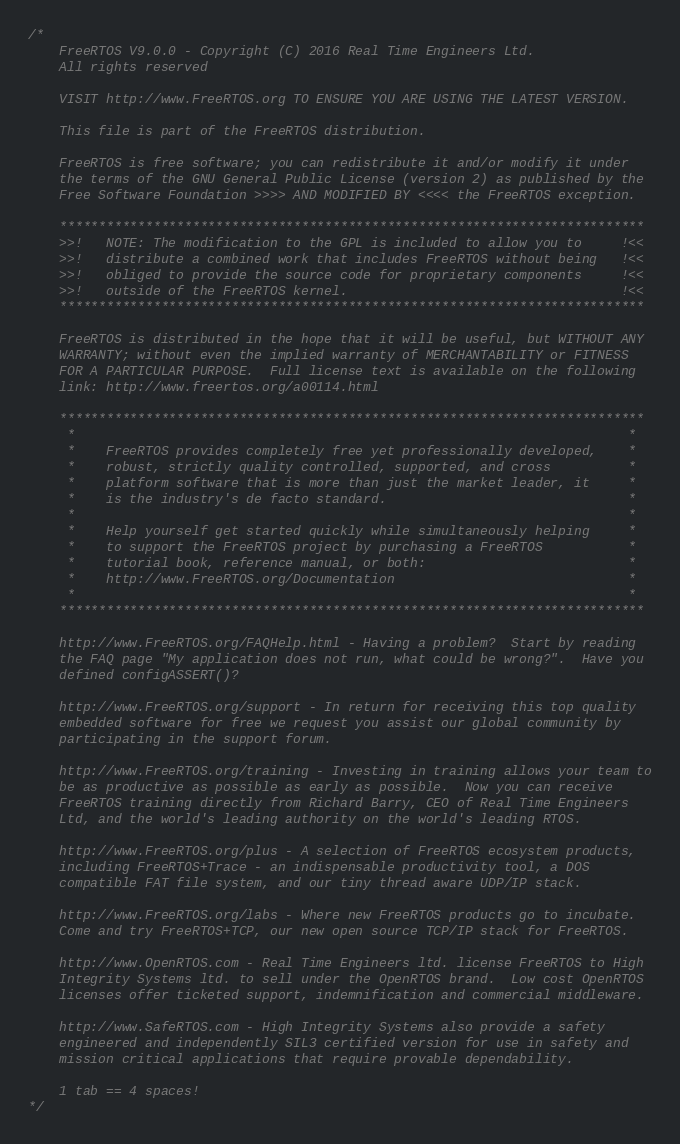Convert code to text. <code><loc_0><loc_0><loc_500><loc_500><_C_>/*
    FreeRTOS V9.0.0 - Copyright (C) 2016 Real Time Engineers Ltd.
    All rights reserved

    VISIT http://www.FreeRTOS.org TO ENSURE YOU ARE USING THE LATEST VERSION.

    This file is part of the FreeRTOS distribution.

    FreeRTOS is free software; you can redistribute it and/or modify it under
    the terms of the GNU General Public License (version 2) as published by the
    Free Software Foundation >>>> AND MODIFIED BY <<<< the FreeRTOS exception.

    ***************************************************************************
    >>!   NOTE: The modification to the GPL is included to allow you to     !<<
    >>!   distribute a combined work that includes FreeRTOS without being   !<<
    >>!   obliged to provide the source code for proprietary components     !<<
    >>!   outside of the FreeRTOS kernel.                                   !<<
    ***************************************************************************

    FreeRTOS is distributed in the hope that it will be useful, but WITHOUT ANY
    WARRANTY; without even the implied warranty of MERCHANTABILITY or FITNESS
    FOR A PARTICULAR PURPOSE.  Full license text is available on the following
    link: http://www.freertos.org/a00114.html

    ***************************************************************************
     *                                                                       *
     *    FreeRTOS provides completely free yet professionally developed,    *
     *    robust, strictly quality controlled, supported, and cross          *
     *    platform software that is more than just the market leader, it     *
     *    is the industry's de facto standard.                               *
     *                                                                       *
     *    Help yourself get started quickly while simultaneously helping     *
     *    to support the FreeRTOS project by purchasing a FreeRTOS           *
     *    tutorial book, reference manual, or both:                          *
     *    http://www.FreeRTOS.org/Documentation                              *
     *                                                                       *
    ***************************************************************************

    http://www.FreeRTOS.org/FAQHelp.html - Having a problem?  Start by reading
    the FAQ page "My application does not run, what could be wrong?".  Have you
    defined configASSERT()?

    http://www.FreeRTOS.org/support - In return for receiving this top quality
    embedded software for free we request you assist our global community by
    participating in the support forum.

    http://www.FreeRTOS.org/training - Investing in training allows your team to
    be as productive as possible as early as possible.  Now you can receive
    FreeRTOS training directly from Richard Barry, CEO of Real Time Engineers
    Ltd, and the world's leading authority on the world's leading RTOS.

    http://www.FreeRTOS.org/plus - A selection of FreeRTOS ecosystem products,
    including FreeRTOS+Trace - an indispensable productivity tool, a DOS
    compatible FAT file system, and our tiny thread aware UDP/IP stack.

    http://www.FreeRTOS.org/labs - Where new FreeRTOS products go to incubate.
    Come and try FreeRTOS+TCP, our new open source TCP/IP stack for FreeRTOS.

    http://www.OpenRTOS.com - Real Time Engineers ltd. license FreeRTOS to High
    Integrity Systems ltd. to sell under the OpenRTOS brand.  Low cost OpenRTOS
    licenses offer ticketed support, indemnification and commercial middleware.

    http://www.SafeRTOS.com - High Integrity Systems also provide a safety
    engineered and independently SIL3 certified version for use in safety and
    mission critical applications that require provable dependability.

    1 tab == 4 spaces!
*/

</code> 